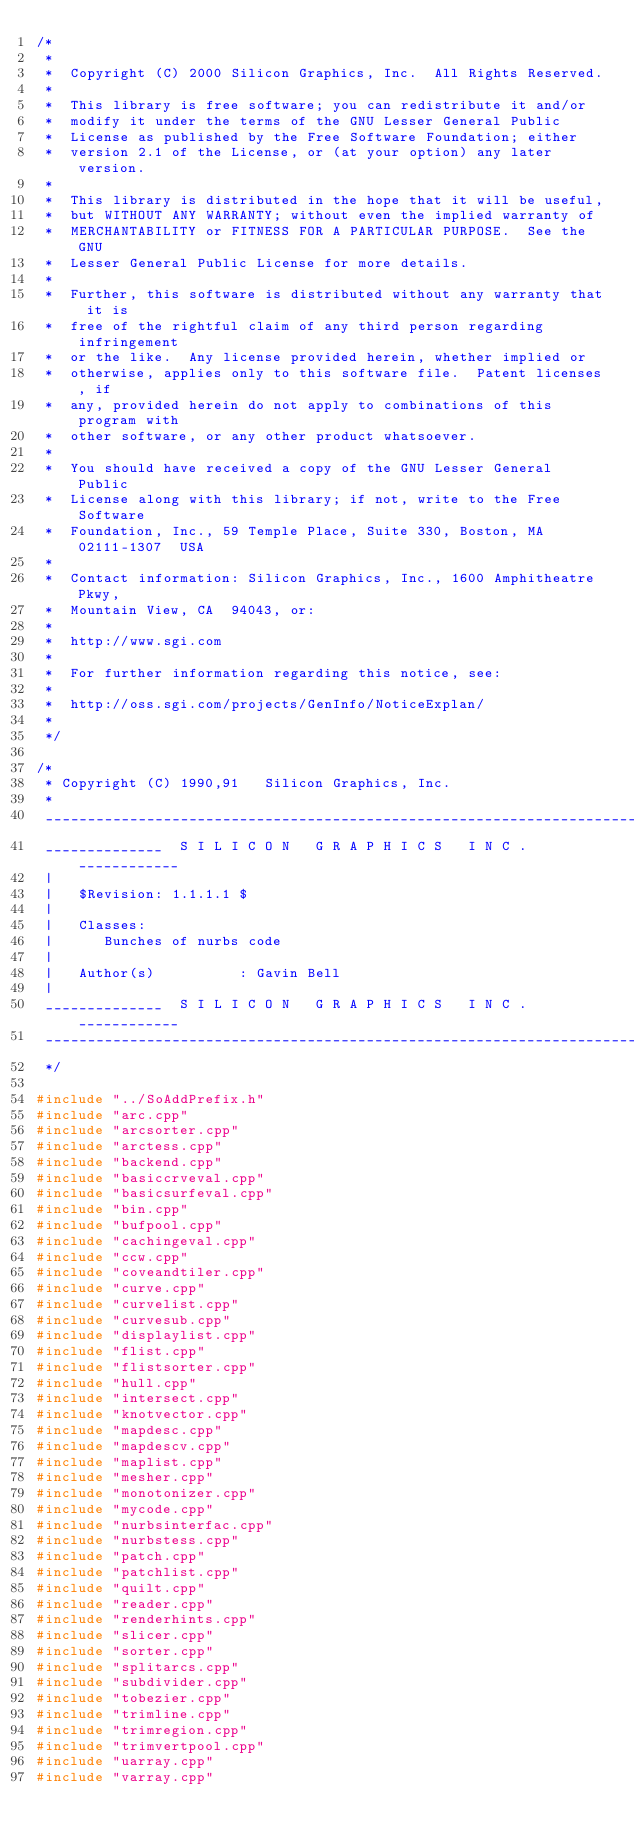<code> <loc_0><loc_0><loc_500><loc_500><_C++_>/*
 *
 *  Copyright (C) 2000 Silicon Graphics, Inc.  All Rights Reserved. 
 *
 *  This library is free software; you can redistribute it and/or
 *  modify it under the terms of the GNU Lesser General Public
 *  License as published by the Free Software Foundation; either
 *  version 2.1 of the License, or (at your option) any later version.
 *
 *  This library is distributed in the hope that it will be useful,
 *  but WITHOUT ANY WARRANTY; without even the implied warranty of
 *  MERCHANTABILITY or FITNESS FOR A PARTICULAR PURPOSE.  See the GNU
 *  Lesser General Public License for more details.
 *
 *  Further, this software is distributed without any warranty that it is
 *  free of the rightful claim of any third person regarding infringement
 *  or the like.  Any license provided herein, whether implied or
 *  otherwise, applies only to this software file.  Patent licenses, if
 *  any, provided herein do not apply to combinations of this program with
 *  other software, or any other product whatsoever.
 * 
 *  You should have received a copy of the GNU Lesser General Public
 *  License along with this library; if not, write to the Free Software
 *  Foundation, Inc., 59 Temple Place, Suite 330, Boston, MA  02111-1307  USA
 *
 *  Contact information: Silicon Graphics, Inc., 1600 Amphitheatre Pkwy,
 *  Mountain View, CA  94043, or:
 * 
 *  http://www.sgi.com 
 * 
 *  For further information regarding this notice, see: 
 * 
 *  http://oss.sgi.com/projects/GenInfo/NoticeExplan/
 *
 */

/*
 * Copyright (C) 1990,91   Silicon Graphics, Inc.
 *
 _______________________________________________________________________
 ______________  S I L I C O N   G R A P H I C S   I N C .  ____________
 |
 |   $Revision: 1.1.1.1 $
 |
 |   Classes:
 |      Bunches of nurbs code
 |
 |   Author(s)          : Gavin Bell
 |
 ______________  S I L I C O N   G R A P H I C S   I N C .  ____________
 _______________________________________________________________________
 */

#include "../SoAddPrefix.h"
#include "arc.cpp"
#include "arcsorter.cpp"
#include "arctess.cpp"
#include "backend.cpp"
#include "basiccrveval.cpp"
#include "basicsurfeval.cpp"
#include "bin.cpp"
#include "bufpool.cpp"
#include "cachingeval.cpp"
#include "ccw.cpp"
#include "coveandtiler.cpp"
#include "curve.cpp"
#include "curvelist.cpp"
#include "curvesub.cpp"
#include "displaylist.cpp"
#include "flist.cpp"
#include "flistsorter.cpp"
#include "hull.cpp"
#include "intersect.cpp"
#include "knotvector.cpp"
#include "mapdesc.cpp"
#include "mapdescv.cpp"
#include "maplist.cpp"
#include "mesher.cpp"
#include "monotonizer.cpp"
#include "mycode.cpp"
#include "nurbsinterfac.cpp"
#include "nurbstess.cpp"
#include "patch.cpp"
#include "patchlist.cpp"
#include "quilt.cpp"
#include "reader.cpp"
#include "renderhints.cpp"
#include "slicer.cpp"
#include "sorter.cpp"
#include "splitarcs.cpp"
#include "subdivider.cpp"
#include "tobezier.cpp"
#include "trimline.cpp"
#include "trimregion.cpp"
#include "trimvertpool.cpp"
#include "uarray.cpp"
#include "varray.cpp"
</code> 